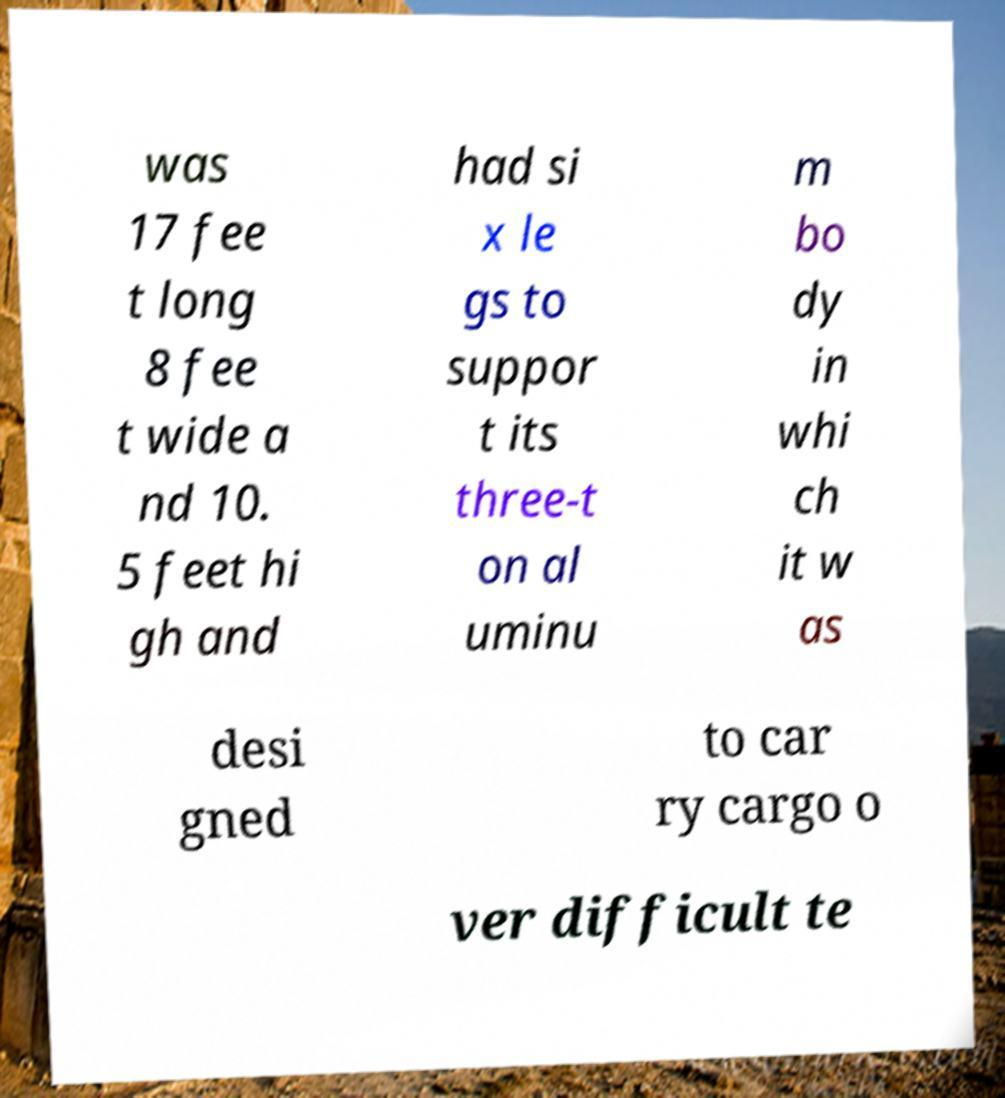There's text embedded in this image that I need extracted. Can you transcribe it verbatim? was 17 fee t long 8 fee t wide a nd 10. 5 feet hi gh and had si x le gs to suppor t its three-t on al uminu m bo dy in whi ch it w as desi gned to car ry cargo o ver difficult te 